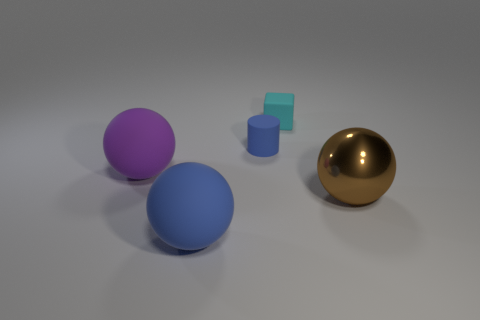Add 3 brown metallic spheres. How many objects exist? 8 Subtract all balls. How many objects are left? 2 Add 1 large brown spheres. How many large brown spheres are left? 2 Add 5 large purple matte spheres. How many large purple matte spheres exist? 6 Subtract 0 red blocks. How many objects are left? 5 Subtract all purple matte objects. Subtract all big purple rubber balls. How many objects are left? 3 